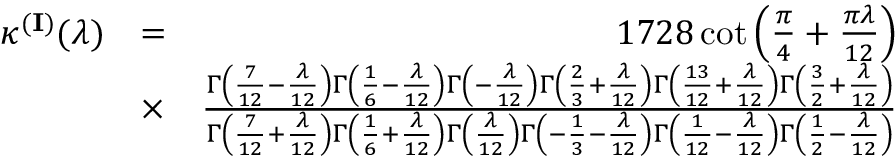<formula> <loc_0><loc_0><loc_500><loc_500>\begin{array} { r l r } { \kappa ^ { ( { I } ) } ( \lambda ) } & { = } & { 1 7 2 8 \cot \left ( \frac { \pi } { 4 } + \frac { \pi \lambda } { 1 2 } \right ) } \\ & { \times } & { \frac { \Gamma \left ( \frac { 7 } { 1 2 } - \frac { \lambda } { 1 2 } \right ) \Gamma \left ( \frac { 1 } { 6 } - \frac { \lambda } { 1 2 } \right ) \Gamma \left ( - \frac { \lambda } { 1 2 } \right ) \Gamma \left ( \frac { 2 } { 3 } + \frac { \lambda } { 1 2 } \right ) \Gamma \left ( \frac { 1 3 } { 1 2 } + \frac { \lambda } { 1 2 } \right ) \Gamma \left ( \frac { 3 } { 2 } + \frac { \lambda } { 1 2 } \right ) } { \Gamma \left ( \frac { 7 } { 1 2 } + \frac { \lambda } { 1 2 } \right ) \Gamma \left ( \frac { 1 } { 6 } + \frac { \lambda } { 1 2 } \right ) \Gamma \left ( \frac { \lambda } { 1 2 } \right ) \Gamma \left ( - \frac { 1 } { 3 } - \frac { \lambda } { 1 2 } \right ) \Gamma \left ( \frac { 1 } { 1 2 } - \frac { \lambda } { 1 2 } \right ) \Gamma \left ( \frac { 1 } { 2 } - \frac { \lambda } { 1 2 } \right ) } } \end{array}</formula> 